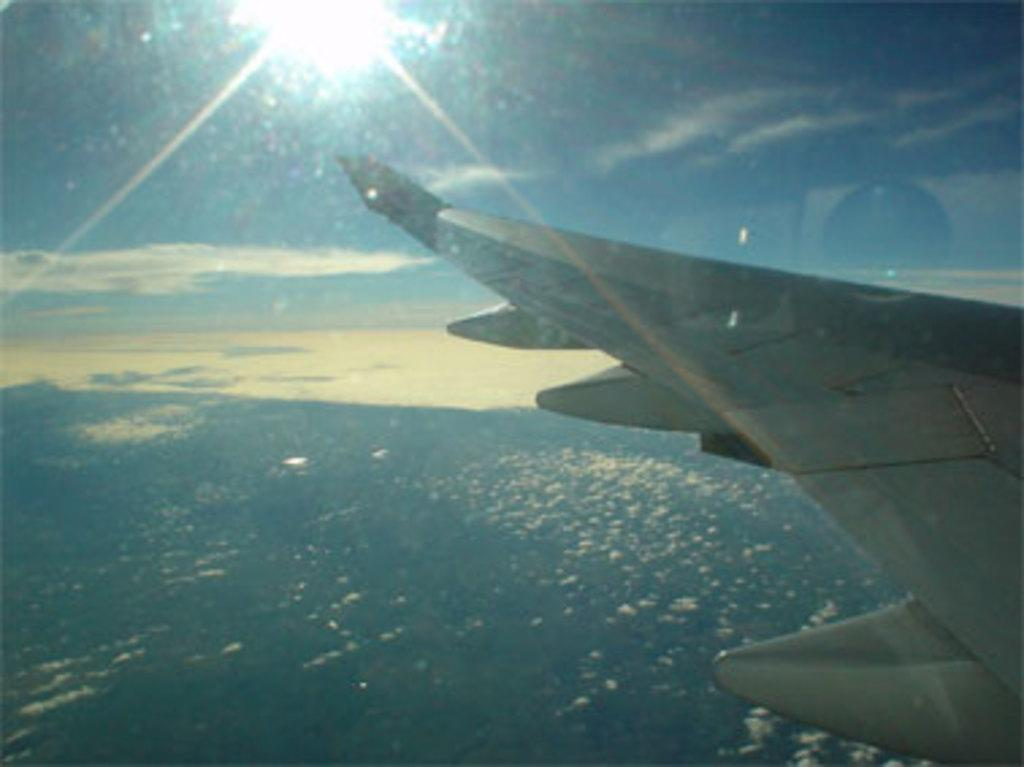What is the perspective of the image? The image is taken from an airplane. What part of the airplane can be seen in the image? The wing of the airplane is visible in the foreground. What is visible at the bottom of the image? There is an aerial view of a city or a forest at the bottom of the image. What can be seen in the sky in the image? The sky is visible in the image, and the sun is shining. What type of square toy can be seen on the wing of the airplane in the image? There is no square toy present on the wing of the airplane in the image. What is the pan used for in the image? There is no pan present in the image. 